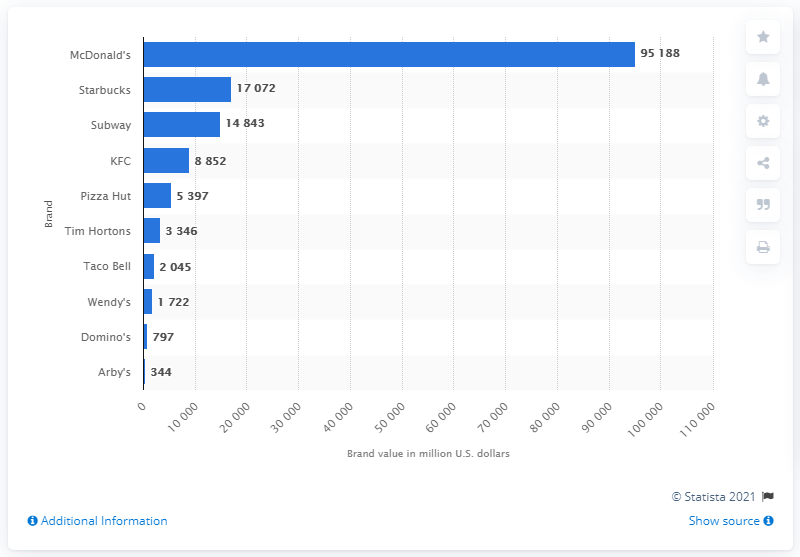Point out several critical features in this image. In 2012, the brand value of Domino's in the United States was approximately 797 dollars. In 2012, McDonald's was the most valuable fast food brand. 